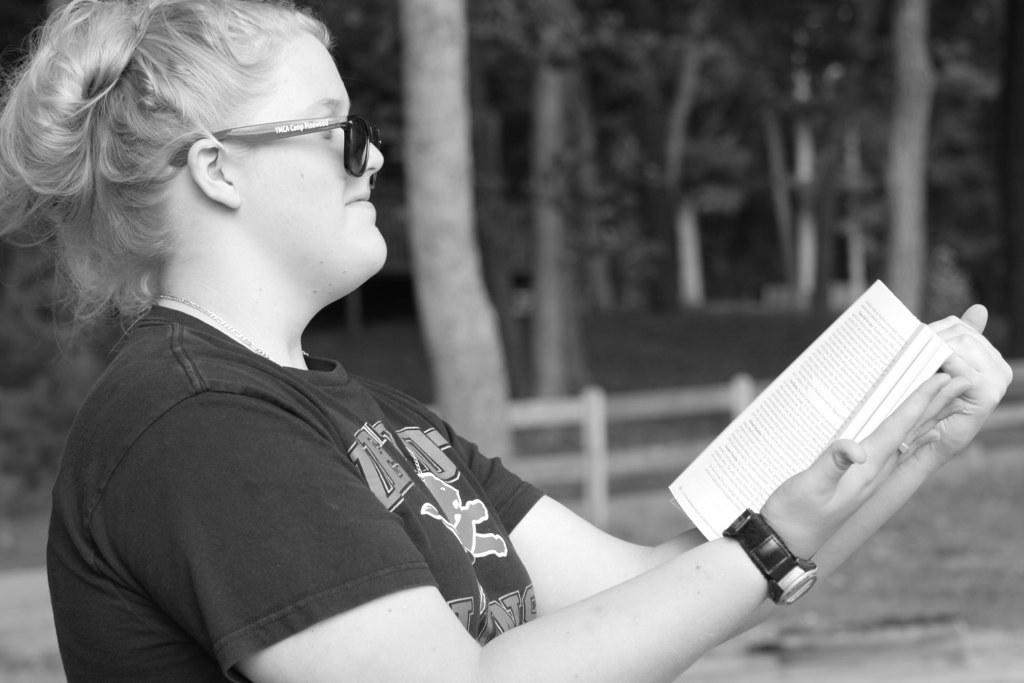Who is the main subject in the foreground of the image? There is a woman in the foreground of the image. What is the woman holding in her hand? The woman is holding a book in her hand. What can be seen in the background of the image? There is a fence and trees in the background of the image. When was the image taken? The image was taken during nighttime. What type of mask is the woman wearing in the image? There is no mask visible on the woman in the image. How many houses are present in the image? There is no mention of houses in the provided facts, so it cannot be determined from the image. 